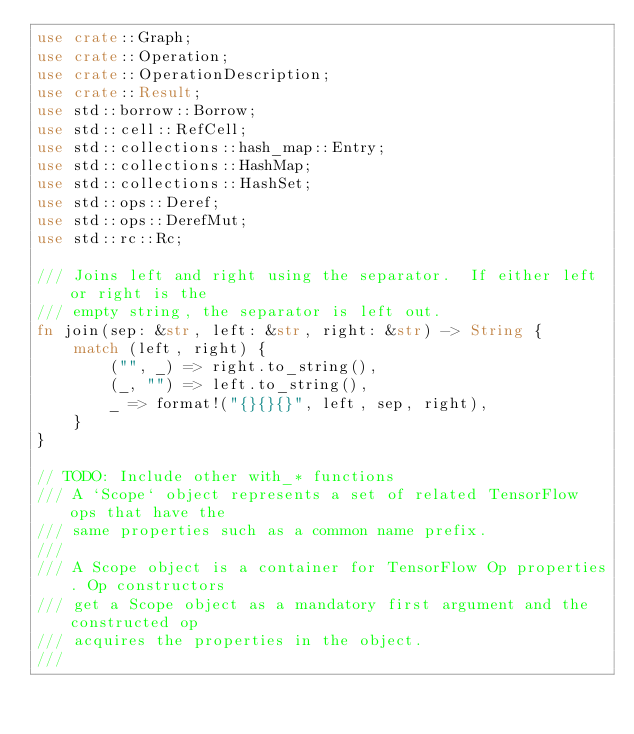<code> <loc_0><loc_0><loc_500><loc_500><_Rust_>use crate::Graph;
use crate::Operation;
use crate::OperationDescription;
use crate::Result;
use std::borrow::Borrow;
use std::cell::RefCell;
use std::collections::hash_map::Entry;
use std::collections::HashMap;
use std::collections::HashSet;
use std::ops::Deref;
use std::ops::DerefMut;
use std::rc::Rc;

/// Joins left and right using the separator.  If either left or right is the
/// empty string, the separator is left out.
fn join(sep: &str, left: &str, right: &str) -> String {
    match (left, right) {
        ("", _) => right.to_string(),
        (_, "") => left.to_string(),
        _ => format!("{}{}{}", left, sep, right),
    }
}

// TODO: Include other with_* functions
/// A `Scope` object represents a set of related TensorFlow ops that have the
/// same properties such as a common name prefix.
///
/// A Scope object is a container for TensorFlow Op properties. Op constructors
/// get a Scope object as a mandatory first argument and the constructed op
/// acquires the properties in the object.
///</code> 